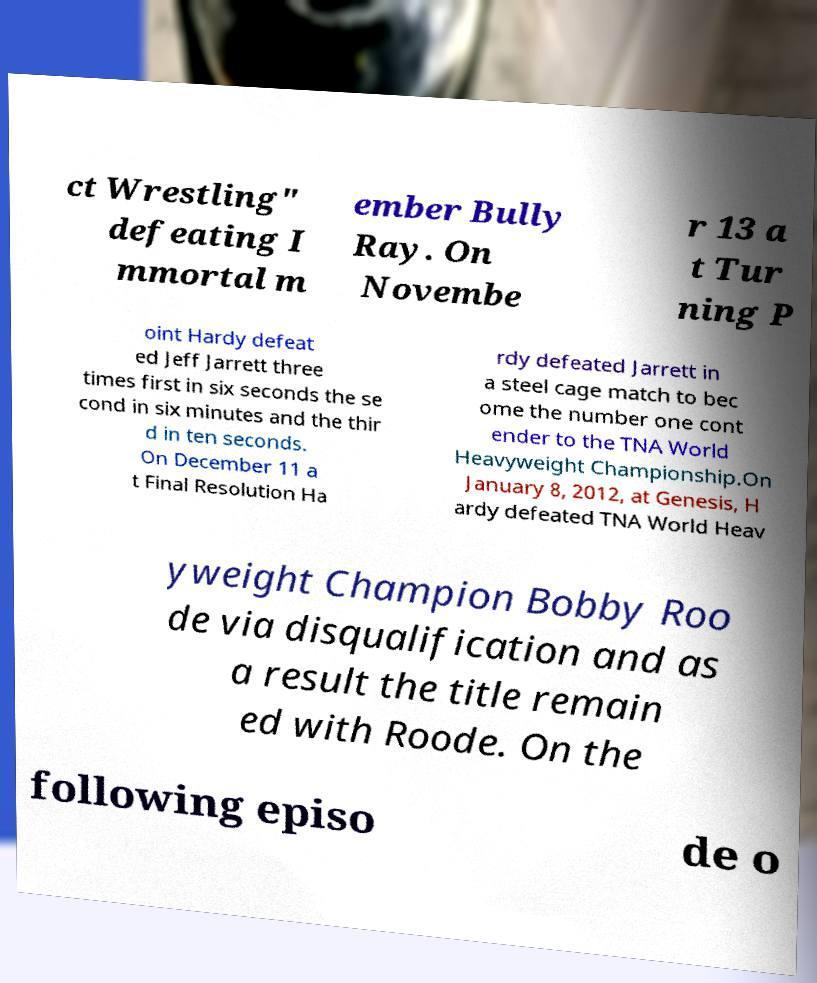Please read and relay the text visible in this image. What does it say? ct Wrestling" defeating I mmortal m ember Bully Ray. On Novembe r 13 a t Tur ning P oint Hardy defeat ed Jeff Jarrett three times first in six seconds the se cond in six minutes and the thir d in ten seconds. On December 11 a t Final Resolution Ha rdy defeated Jarrett in a steel cage match to bec ome the number one cont ender to the TNA World Heavyweight Championship.On January 8, 2012, at Genesis, H ardy defeated TNA World Heav yweight Champion Bobby Roo de via disqualification and as a result the title remain ed with Roode. On the following episo de o 